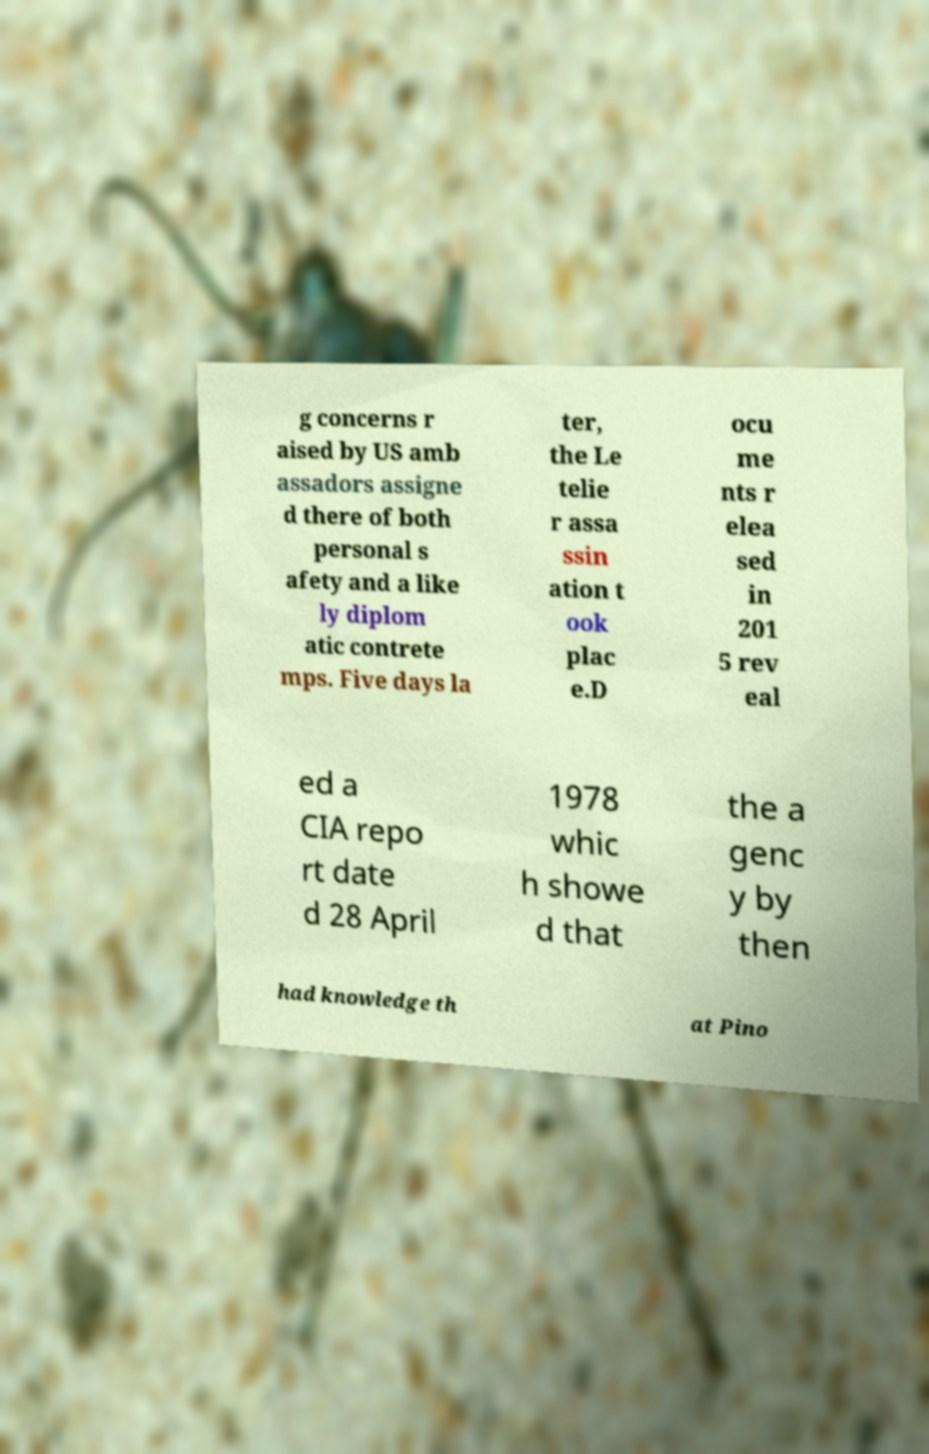For documentation purposes, I need the text within this image transcribed. Could you provide that? g concerns r aised by US amb assadors assigne d there of both personal s afety and a like ly diplom atic contrete mps. Five days la ter, the Le telie r assa ssin ation t ook plac e.D ocu me nts r elea sed in 201 5 rev eal ed a CIA repo rt date d 28 April 1978 whic h showe d that the a genc y by then had knowledge th at Pino 